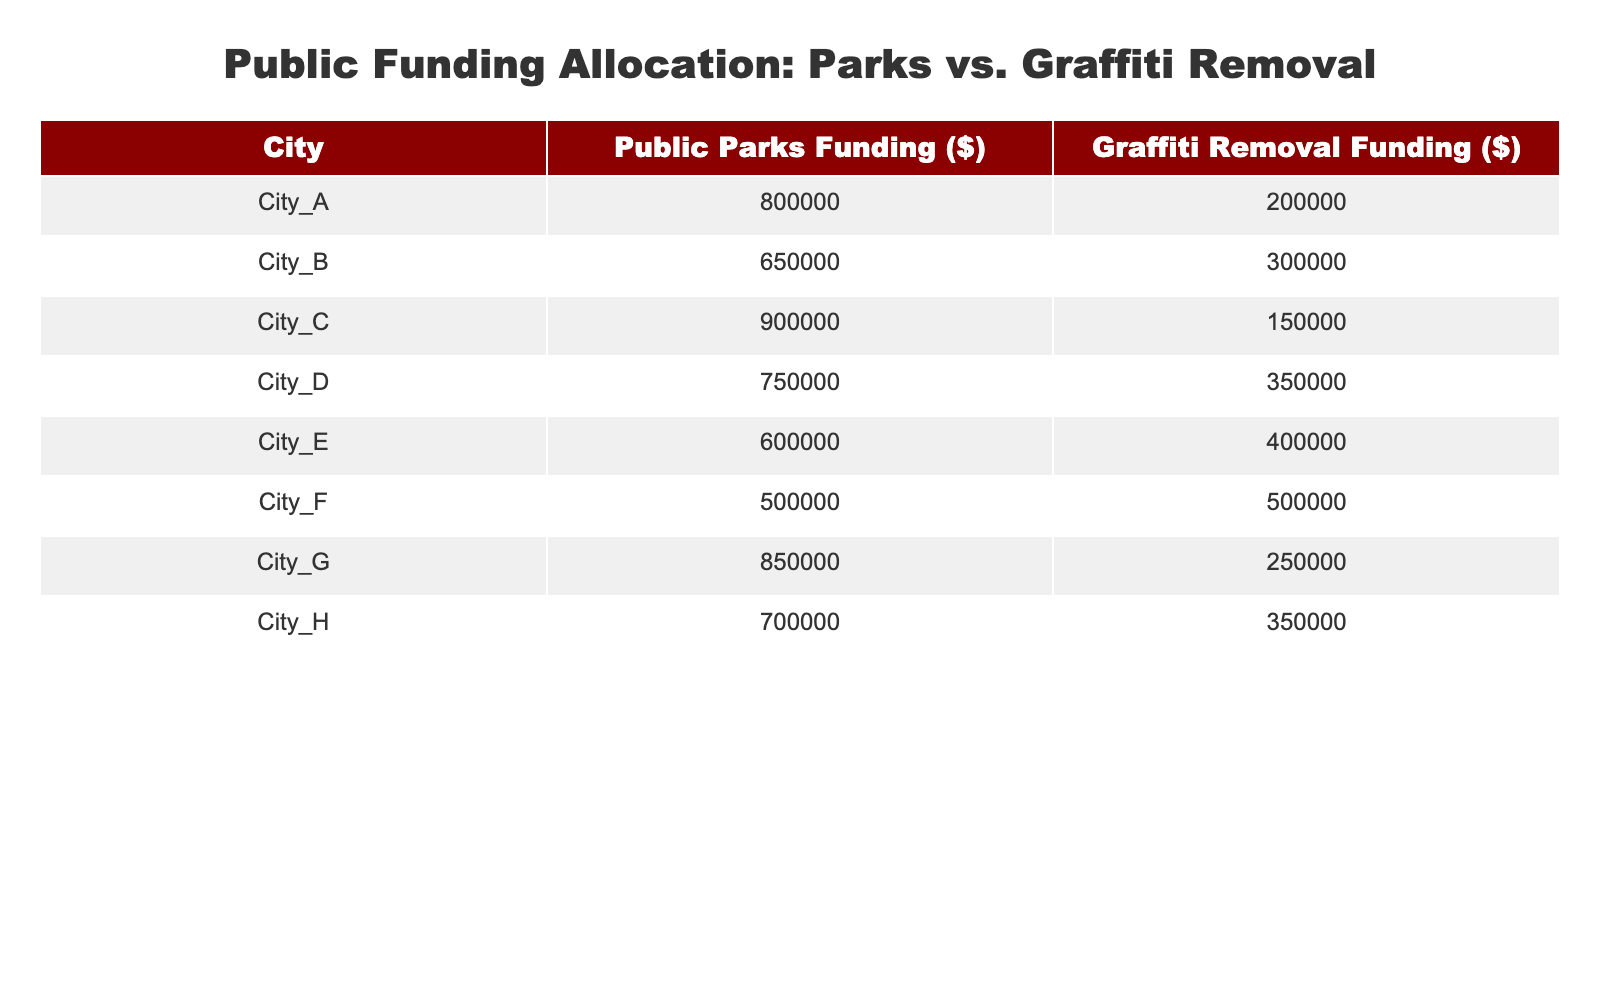What is the highest funding allocated to public parks among the cities? By examining the 'Public Parks Funding' column, City C has the highest value of 900000, which is greater than any other city's funding for public parks.
Answer: 900000 Which city received the least funding for graffiti removal services? Looking at the 'Graffiti Removal Funding' column, City C shows the lowest value at 150000 when compared to other cities.
Answer: City C What is the total funding allocated to graffiti removal services across all cities? Adding the values for 'Public Graffiti Removal Services' from all cities: 200000 + 300000 + 150000 + 350000 + 400000 + 500000 + 250000 + 350000 equals 2500000.
Answer: 2500000 Is the funding allocated for public parks greater than the funding for graffiti removal services in all cities? By checking each city, we find City F where funding for parks (500000) is equal to graffiti removal (500000), meaning it is not greater in that instance, so the statement is false.
Answer: No What is the average funding for public parks across all cities? To find the average, first sum the values: 800000 + 650000 + 900000 + 750000 + 600000 + 500000 + 850000 + 700000 equals 4950000. Then divide by the number of cities (8), which is 4950000/8 = 618750.
Answer: 618750 Which city has a funding difference of more than 100000 between public parks and graffiti removal services? First, we calculate the difference for each city: City A (600000), City B (350000), City C (750000), City D (400000), City E (200000), City F (0), City G (600000), City H (350000). All cities except City F have a difference greater than 100000.
Answer: City A, City B, City C, City D, City E, City G, City H What is the total funding allocated for public parks in cities that have funding for graffiti removal above 300000? The cities with graffiti funding above 300000 are City B, City D, City E, and City F. Adding their parks funding gives: 650000 (City B) + 750000 (City D) + 600000 (City E) + 500000 (City F) totals 2500000.
Answer: 2500000 